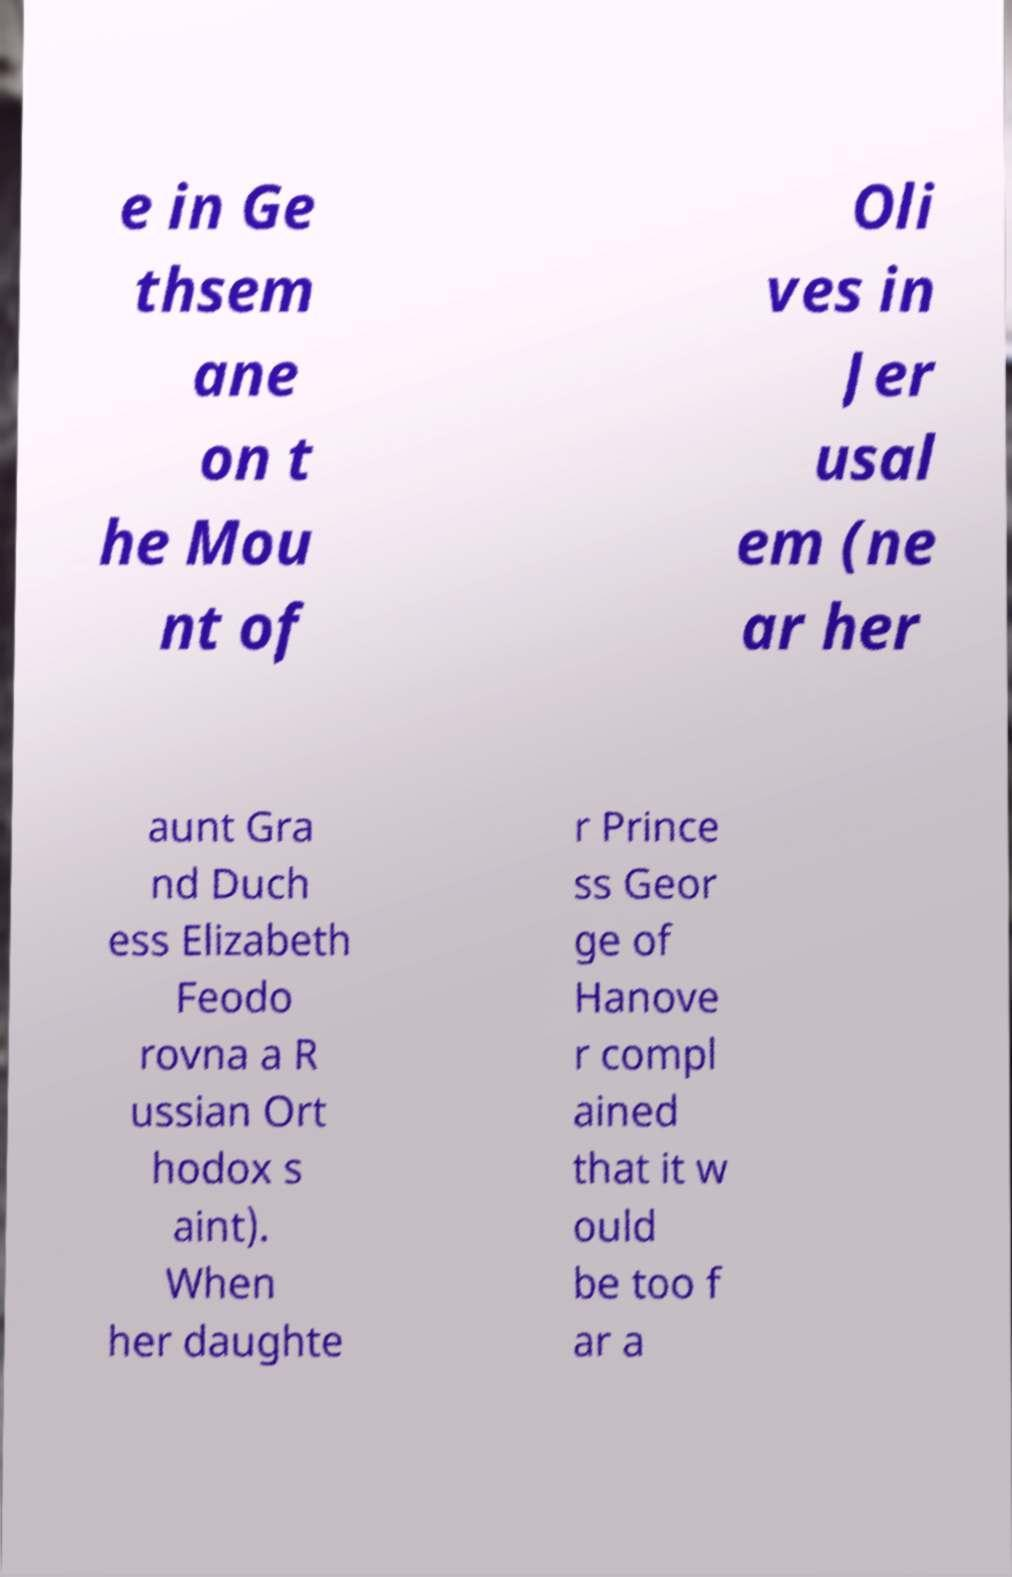Can you accurately transcribe the text from the provided image for me? e in Ge thsem ane on t he Mou nt of Oli ves in Jer usal em (ne ar her aunt Gra nd Duch ess Elizabeth Feodo rovna a R ussian Ort hodox s aint). When her daughte r Prince ss Geor ge of Hanove r compl ained that it w ould be too f ar a 